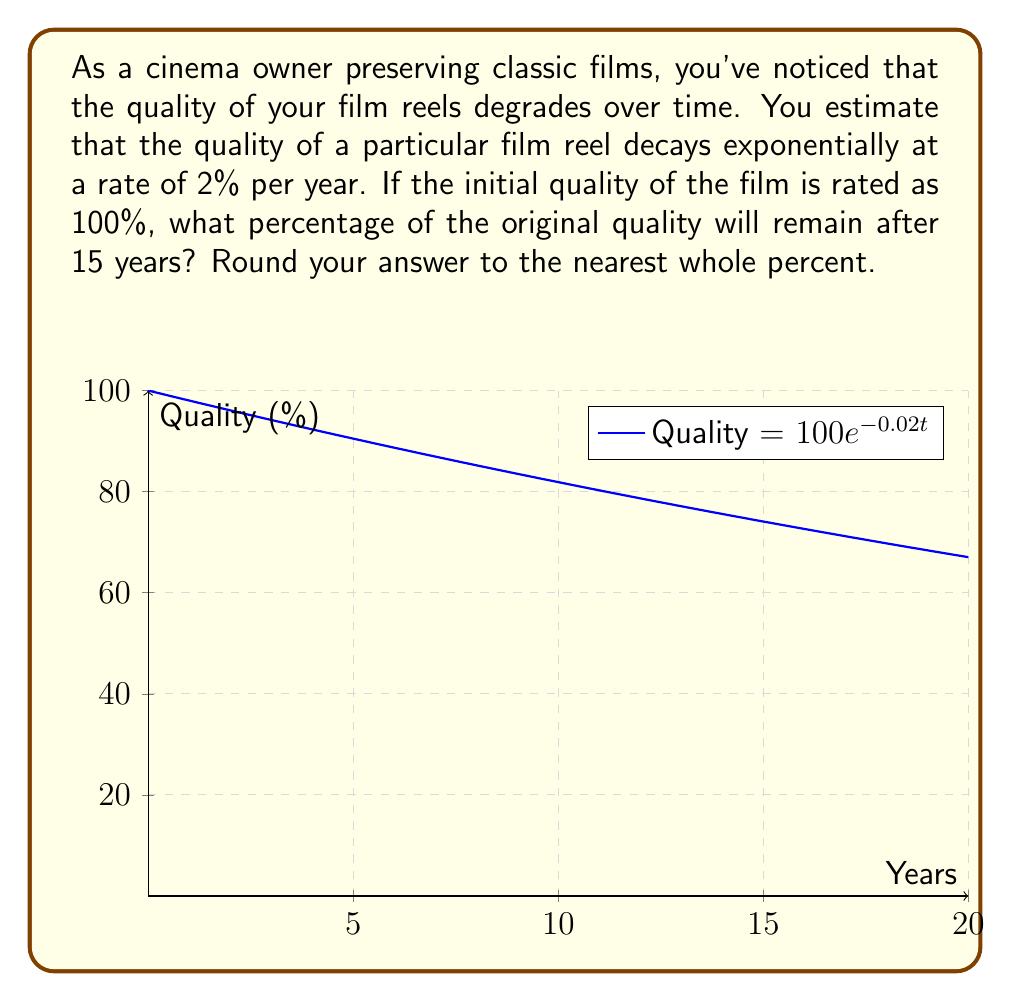Could you help me with this problem? Let's approach this step-by-step using an exponential decay function:

1) The general form of an exponential decay function is:

   $$A(t) = A_0 e^{-rt}$$

   Where:
   $A(t)$ is the amount at time $t$
   $A_0$ is the initial amount
   $r$ is the decay rate
   $t$ is the time

2) In this case:
   $A_0 = 100\%$ (initial quality)
   $r = 0.02$ (2% decay rate per year)
   $t = 15$ years

3) Plugging these values into our equation:

   $$A(15) = 100 e^{-0.02 \cdot 15}$$

4) Let's calculate this:
   
   $$A(15) = 100 e^{-0.3}$$

5) Using a calculator or computer:

   $$A(15) \approx 100 \cdot 0.7408 = 74.08\%$$

6) Rounding to the nearest whole percent:

   $$A(15) \approx 74\%$$

Therefore, after 15 years, approximately 74% of the original quality will remain.
Answer: 74% 